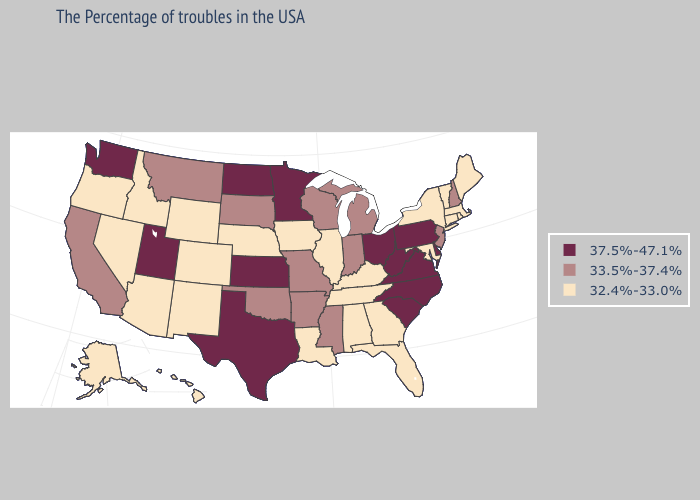Which states have the highest value in the USA?
Keep it brief. Delaware, Pennsylvania, Virginia, North Carolina, South Carolina, West Virginia, Ohio, Minnesota, Kansas, Texas, North Dakota, Utah, Washington. What is the value of Illinois?
Write a very short answer. 32.4%-33.0%. What is the lowest value in the West?
Answer briefly. 32.4%-33.0%. Does Nevada have a lower value than New Mexico?
Short answer required. No. What is the value of West Virginia?
Keep it brief. 37.5%-47.1%. Which states hav the highest value in the MidWest?
Short answer required. Ohio, Minnesota, Kansas, North Dakota. What is the value of Delaware?
Quick response, please. 37.5%-47.1%. Is the legend a continuous bar?
Be succinct. No. What is the value of Kentucky?
Short answer required. 32.4%-33.0%. Which states have the lowest value in the South?
Give a very brief answer. Maryland, Florida, Georgia, Kentucky, Alabama, Tennessee, Louisiana. How many symbols are there in the legend?
Give a very brief answer. 3. What is the value of Washington?
Write a very short answer. 37.5%-47.1%. What is the lowest value in the West?
Keep it brief. 32.4%-33.0%. What is the value of New York?
Be succinct. 32.4%-33.0%. Does the first symbol in the legend represent the smallest category?
Be succinct. No. 